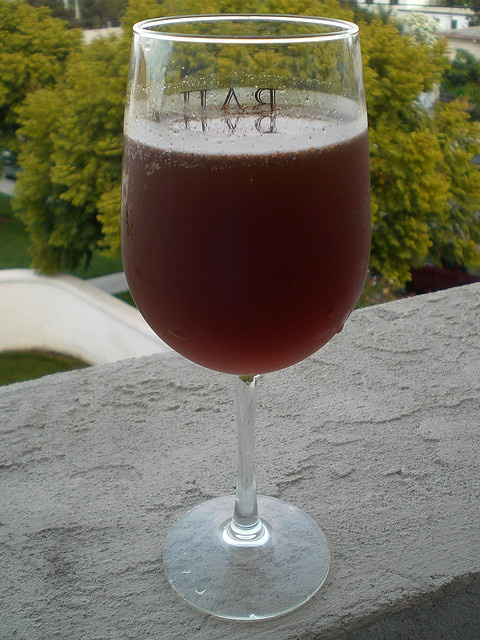Describe the objects in this image and their specific colors. I can see wine glass in olive, black, darkgray, maroon, and gray tones in this image. 